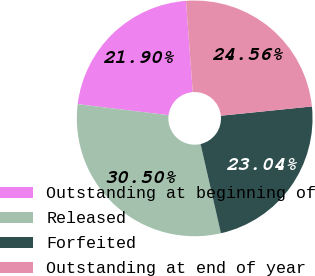<chart> <loc_0><loc_0><loc_500><loc_500><pie_chart><fcel>Outstanding at beginning of<fcel>Released<fcel>Forfeited<fcel>Outstanding at end of year<nl><fcel>21.9%<fcel>30.5%<fcel>23.04%<fcel>24.56%<nl></chart> 